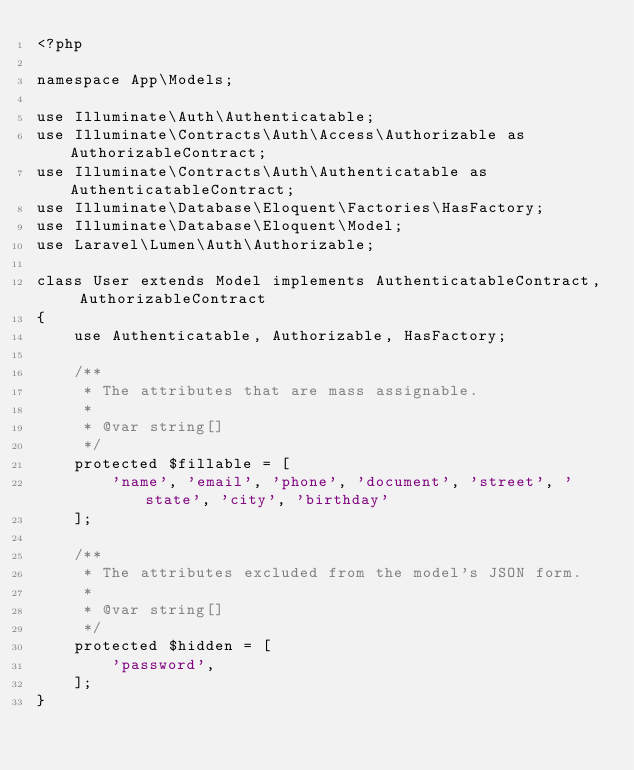Convert code to text. <code><loc_0><loc_0><loc_500><loc_500><_PHP_><?php

namespace App\Models;

use Illuminate\Auth\Authenticatable;
use Illuminate\Contracts\Auth\Access\Authorizable as AuthorizableContract;
use Illuminate\Contracts\Auth\Authenticatable as AuthenticatableContract;
use Illuminate\Database\Eloquent\Factories\HasFactory;
use Illuminate\Database\Eloquent\Model;
use Laravel\Lumen\Auth\Authorizable;

class User extends Model implements AuthenticatableContract, AuthorizableContract
{
    use Authenticatable, Authorizable, HasFactory;

    /**
     * The attributes that are mass assignable.
     *
     * @var string[]
     */
    protected $fillable = [
        'name', 'email', 'phone', 'document', 'street', 'state', 'city', 'birthday'
    ];

    /**
     * The attributes excluded from the model's JSON form.
     *
     * @var string[]
     */
    protected $hidden = [
        'password',
    ];
}
</code> 